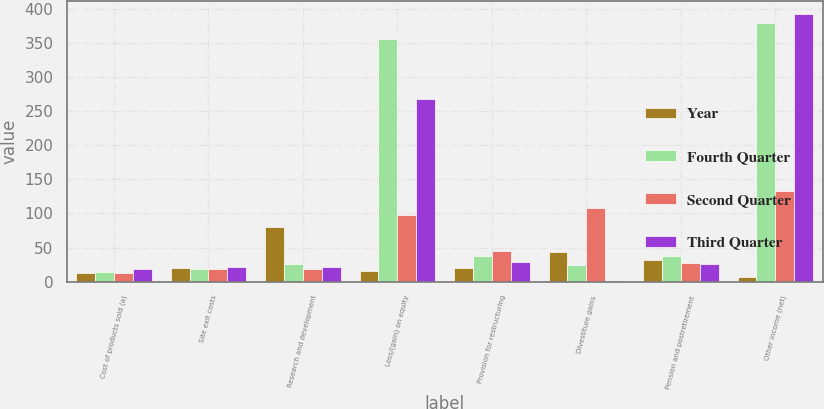<chart> <loc_0><loc_0><loc_500><loc_500><stacked_bar_chart><ecel><fcel>Cost of products sold (a)<fcel>Site exit costs<fcel>Research and development<fcel>Loss/(gain) on equity<fcel>Provision for restructuring<fcel>Divestiture gains<fcel>Pension and postretirement<fcel>Other income (net)<nl><fcel>Year<fcel>13<fcel>20<fcel>80<fcel>15<fcel>20<fcel>43<fcel>31<fcel>7<nl><fcel>Fourth Quarter<fcel>14<fcel>19<fcel>26<fcel>356<fcel>37<fcel>25<fcel>37<fcel>380<nl><fcel>Second Quarter<fcel>13<fcel>18<fcel>18<fcel>97<fcel>45<fcel>108<fcel>27<fcel>133<nl><fcel>Third Quarter<fcel>18<fcel>22<fcel>22<fcel>268<fcel>29<fcel>1<fcel>26<fcel>392<nl></chart> 